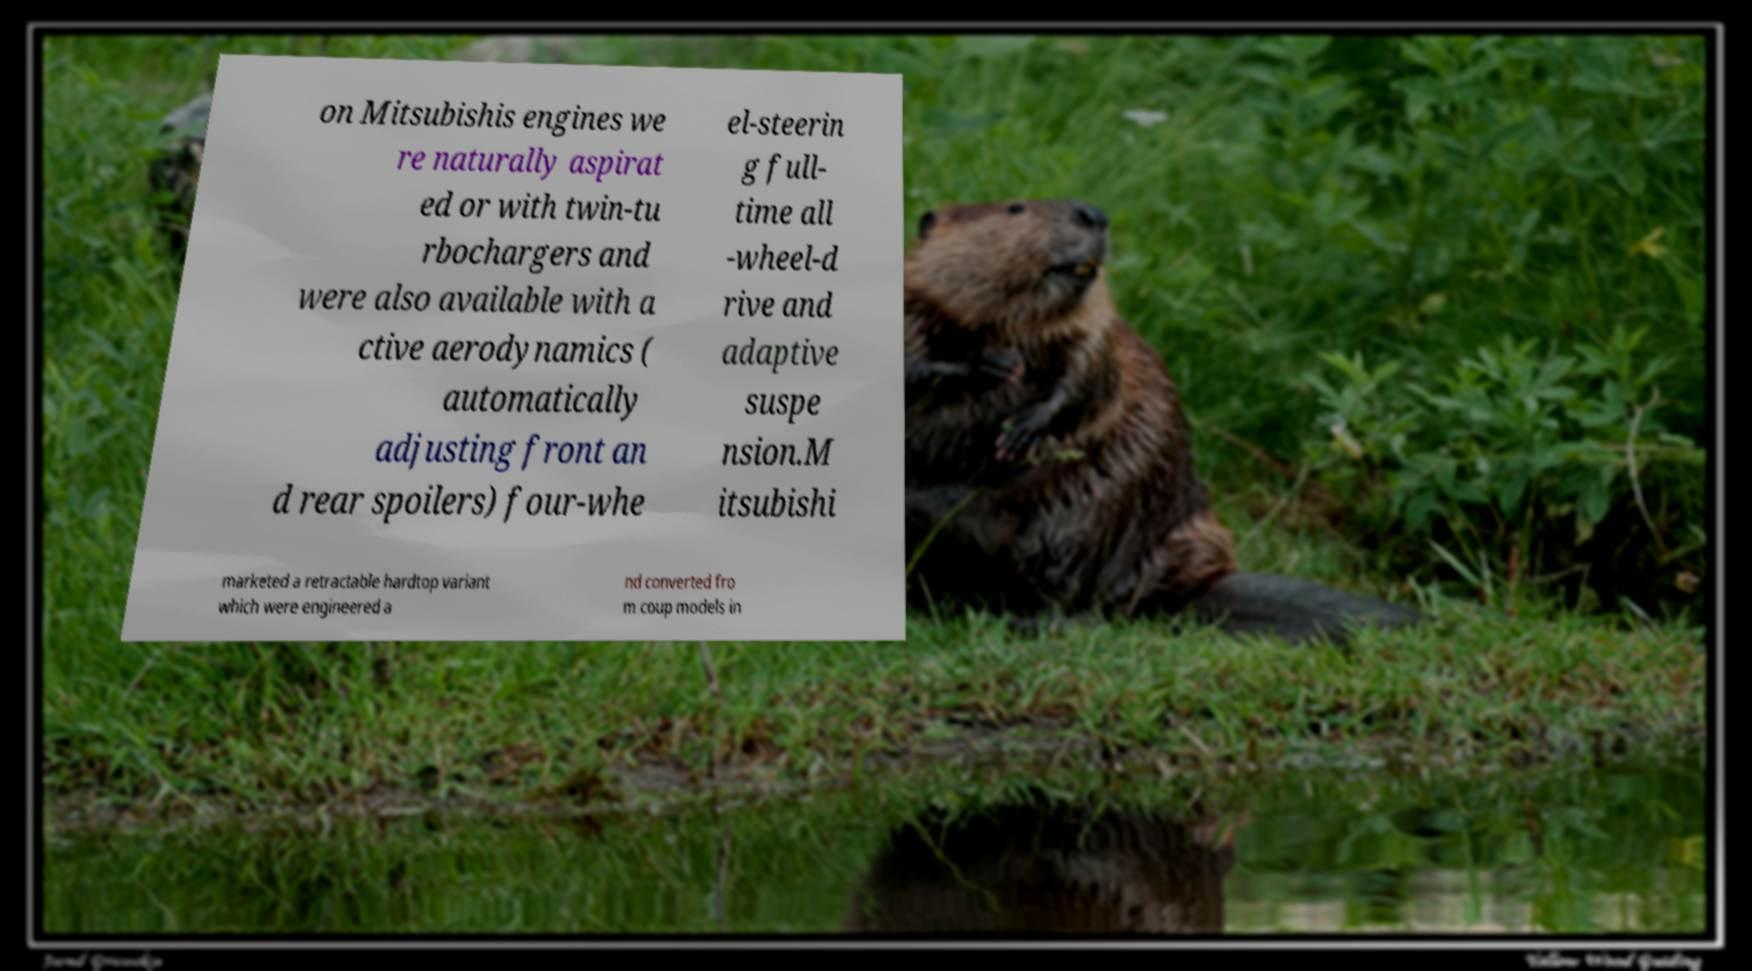Please read and relay the text visible in this image. What does it say? on Mitsubishis engines we re naturally aspirat ed or with twin-tu rbochargers and were also available with a ctive aerodynamics ( automatically adjusting front an d rear spoilers) four-whe el-steerin g full- time all -wheel-d rive and adaptive suspe nsion.M itsubishi marketed a retractable hardtop variant which were engineered a nd converted fro m coup models in 